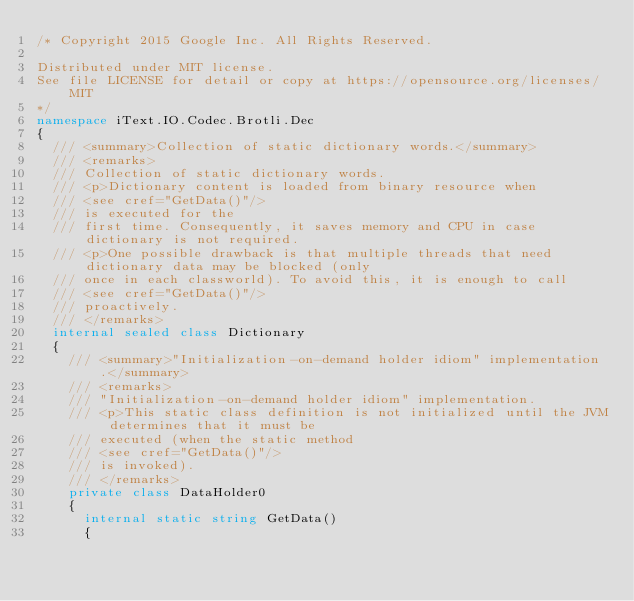Convert code to text. <code><loc_0><loc_0><loc_500><loc_500><_C#_>/* Copyright 2015 Google Inc. All Rights Reserved.

Distributed under MIT license.
See file LICENSE for detail or copy at https://opensource.org/licenses/MIT
*/
namespace iText.IO.Codec.Brotli.Dec
{
	/// <summary>Collection of static dictionary words.</summary>
	/// <remarks>
	/// Collection of static dictionary words.
	/// <p>Dictionary content is loaded from binary resource when
	/// <see cref="GetData()"/>
	/// is executed for the
	/// first time. Consequently, it saves memory and CPU in case dictionary is not required.
	/// <p>One possible drawback is that multiple threads that need dictionary data may be blocked (only
	/// once in each classworld). To avoid this, it is enough to call
	/// <see cref="GetData()"/>
	/// proactively.
	/// </remarks>
	internal sealed class Dictionary
	{
		/// <summary>"Initialization-on-demand holder idiom" implementation.</summary>
		/// <remarks>
		/// "Initialization-on-demand holder idiom" implementation.
		/// <p>This static class definition is not initialized until the JVM determines that it must be
		/// executed (when the static method
		/// <see cref="GetData()"/>
		/// is invoked).
		/// </remarks>
		private class DataHolder0
		{
			internal static string GetData()
			{</code> 